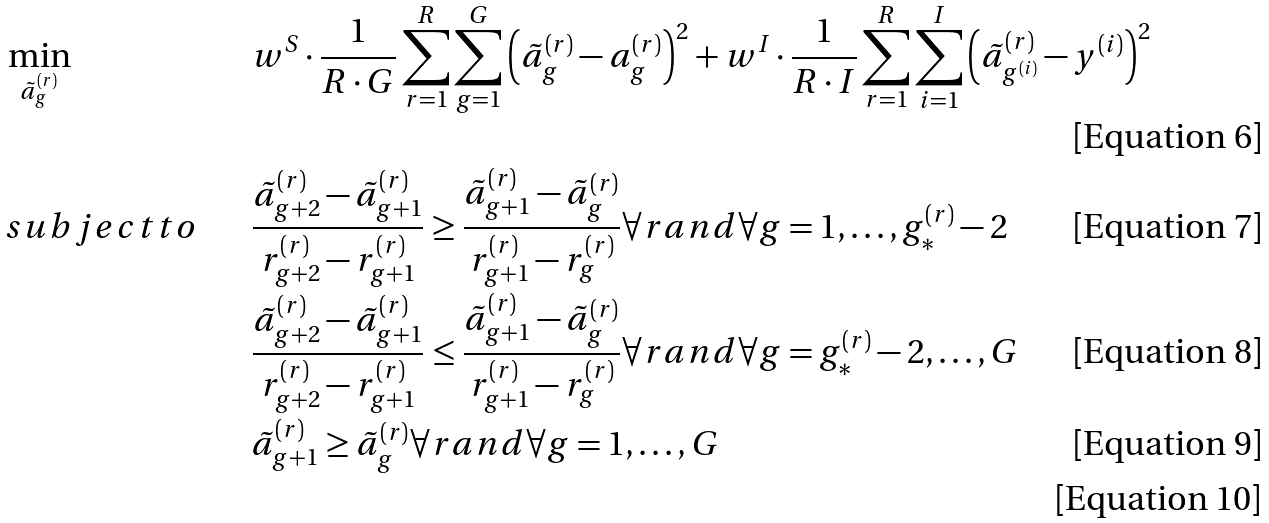<formula> <loc_0><loc_0><loc_500><loc_500>& \min _ { \tilde { a } _ { g } ^ { ( r ) } } & & w ^ { S } \cdot \frac { 1 } { R \cdot G } \sum _ { r = 1 } ^ { R } \sum _ { g = 1 } ^ { G } \left ( \tilde { a } _ { g } ^ { ( r ) } - a _ { g } ^ { ( r ) } \right ) ^ { 2 } + w ^ { I } \cdot \frac { 1 } { R \cdot I } \sum _ { r = 1 } ^ { R } \sum _ { i = 1 } ^ { I } \left ( \tilde { a } _ { g ^ { ( i ) } } ^ { ( r ) } - y ^ { ( i ) } \right ) ^ { 2 } \\ & s u b j e c t t o & & \frac { \tilde { a } _ { g + 2 } ^ { ( r ) } - \tilde { a } _ { g + 1 } ^ { ( r ) } } { r _ { g + 2 } ^ { ( r ) } - r _ { g + 1 } ^ { ( r ) } } \geq \frac { \tilde { a } _ { g + 1 } ^ { ( r ) } - \tilde { a } _ { g } ^ { ( r ) } } { r _ { g + 1 } ^ { ( r ) } - r _ { g } ^ { ( r ) } } \forall r a n d \forall g = 1 , \dots , g _ { * } ^ { ( r ) } - 2 \\ & & & \frac { \tilde { a } _ { g + 2 } ^ { ( r ) } - \tilde { a } _ { g + 1 } ^ { ( r ) } } { r _ { g + 2 } ^ { ( r ) } - r _ { g + 1 } ^ { ( r ) } } \leq \frac { \tilde { a } _ { g + 1 } ^ { ( r ) } - \tilde { a } _ { g } ^ { ( r ) } } { r _ { g + 1 } ^ { ( r ) } - r _ { g } ^ { ( r ) } } \forall r a n d \forall g = g _ { * } ^ { ( r ) } - 2 , \dots , G \\ & & & \tilde { a } _ { g + 1 } ^ { ( r ) } \geq \tilde { a } _ { g } ^ { ( r ) } \forall r a n d \forall g = 1 , \dots , G \\</formula> 